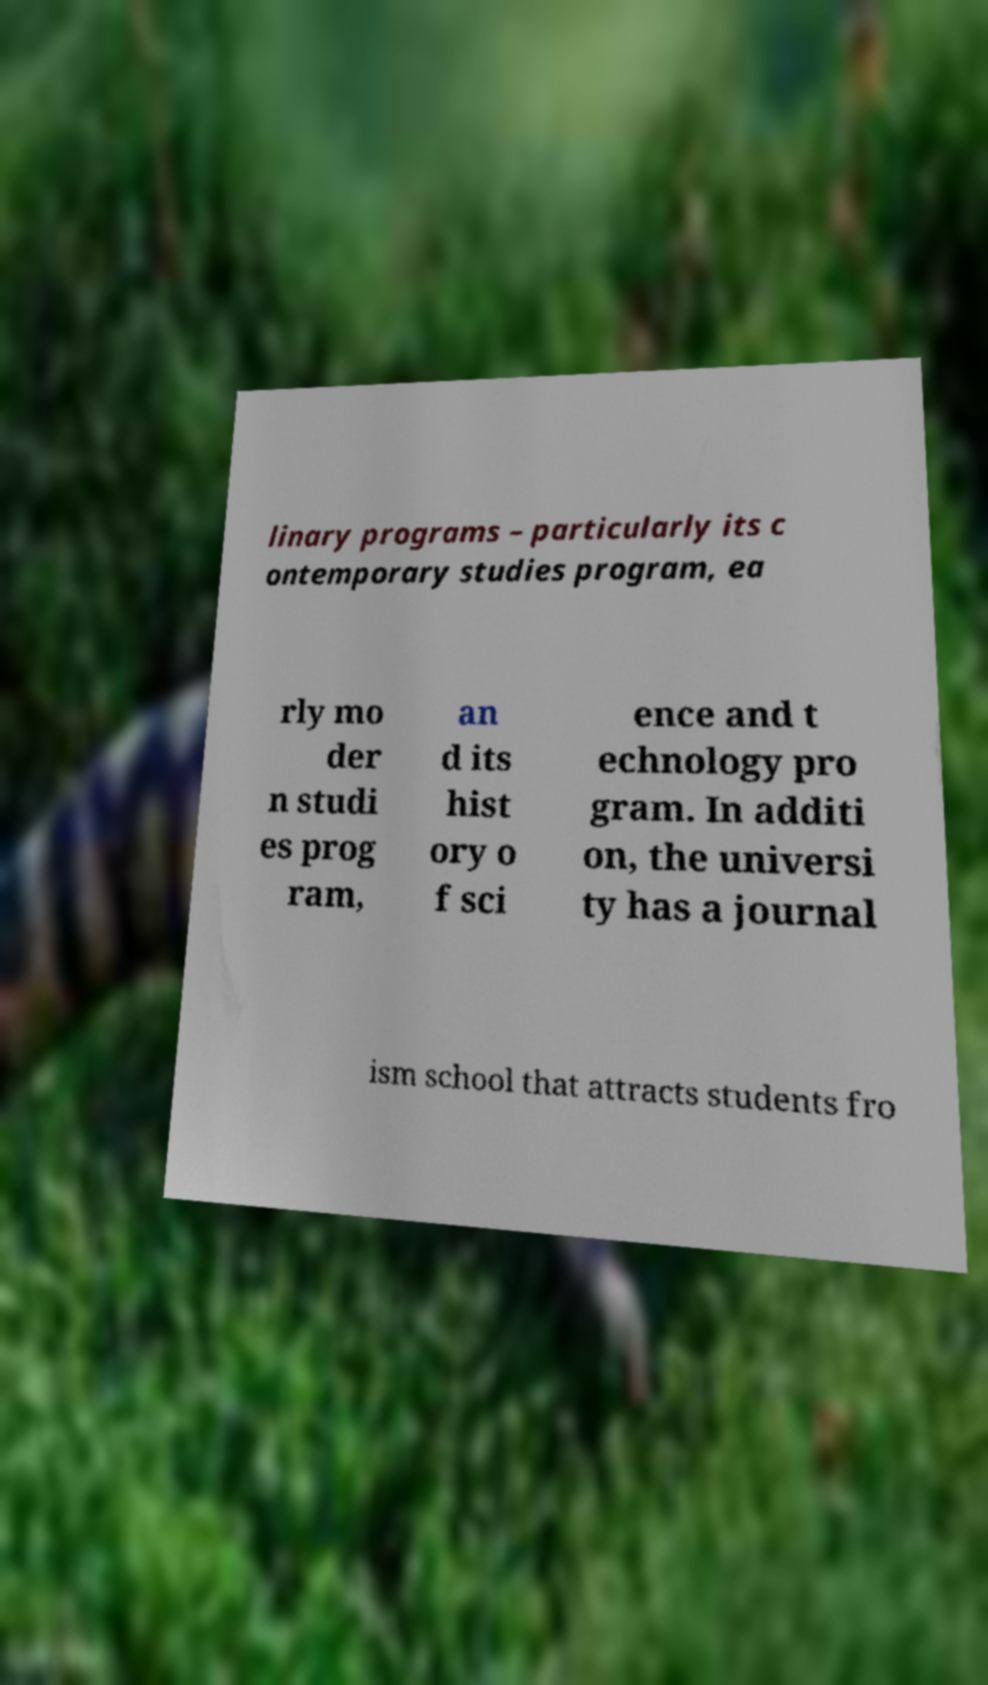Could you assist in decoding the text presented in this image and type it out clearly? linary programs – particularly its c ontemporary studies program, ea rly mo der n studi es prog ram, an d its hist ory o f sci ence and t echnology pro gram. In additi on, the universi ty has a journal ism school that attracts students fro 